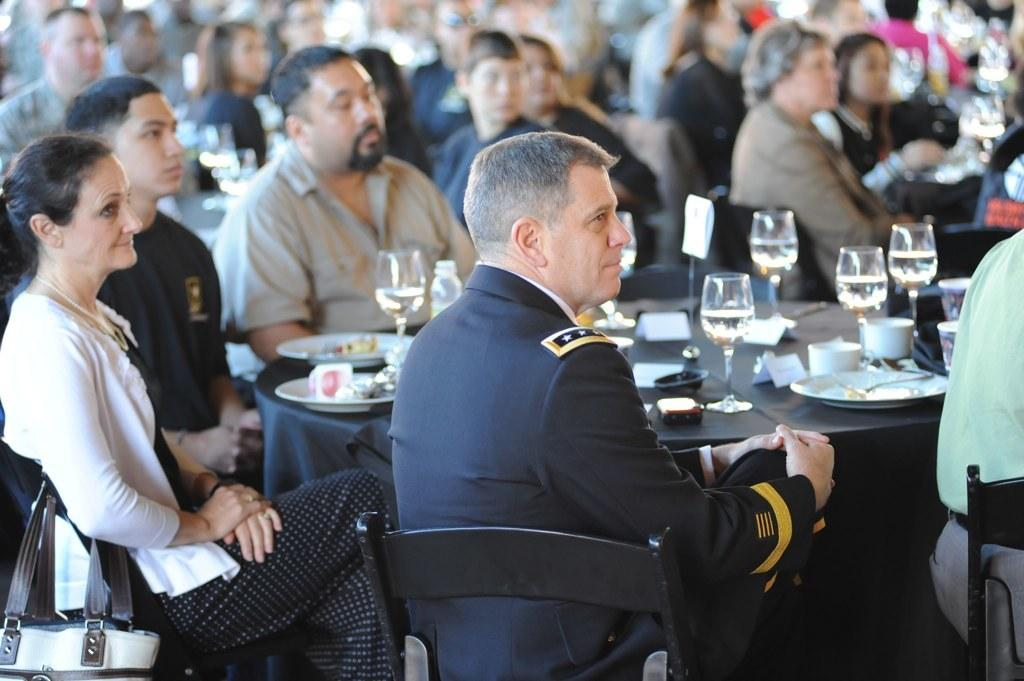How many people are in the image? There is a group of people in the image. What are the people doing in the image? The people are sitting on chairs. What is on the table in the image? There is a plate and a glass present on the table. What type of cough can be heard from the people in the image? There is no indication of any cough in the image, as it only shows a group of people sitting on chairs. 